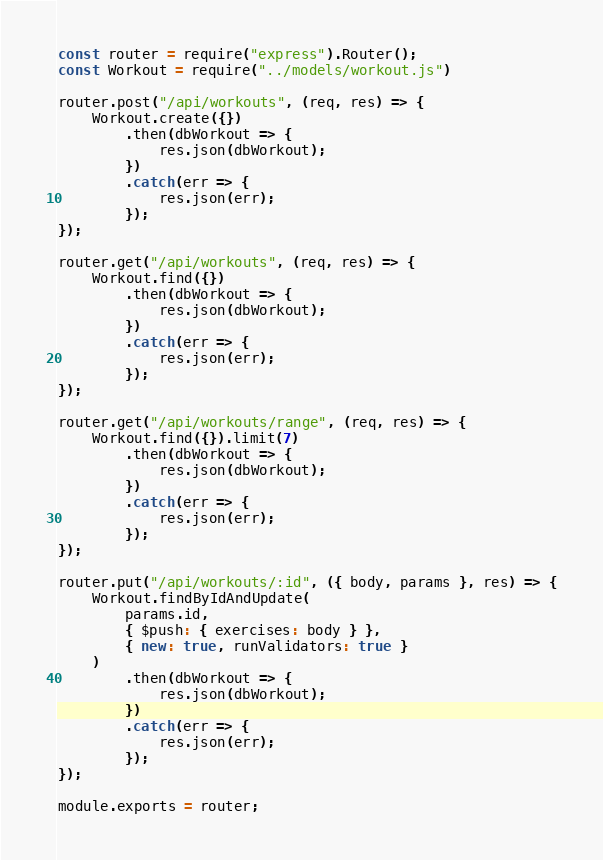Convert code to text. <code><loc_0><loc_0><loc_500><loc_500><_JavaScript_>const router = require("express").Router();
const Workout = require("../models/workout.js")

router.post("/api/workouts", (req, res) => {
    Workout.create({})
        .then(dbWorkout => {
            res.json(dbWorkout);
        })
        .catch(err => {
            res.json(err);
        });
});

router.get("/api/workouts", (req, res) => {
    Workout.find({})
        .then(dbWorkout => {
            res.json(dbWorkout);
        })
        .catch(err => {
            res.json(err);
        });
});

router.get("/api/workouts/range", (req, res) => {
    Workout.find({}).limit(7)
        .then(dbWorkout => {
            res.json(dbWorkout);
        })
        .catch(err => {
            res.json(err);
        });
});

router.put("/api/workouts/:id", ({ body, params }, res) => {
    Workout.findByIdAndUpdate(
        params.id,
        { $push: { exercises: body } },
        { new: true, runValidators: true }
    )
        .then(dbWorkout => {
            res.json(dbWorkout);
        })
        .catch(err => {
            res.json(err);
        });
});

module.exports = router;</code> 